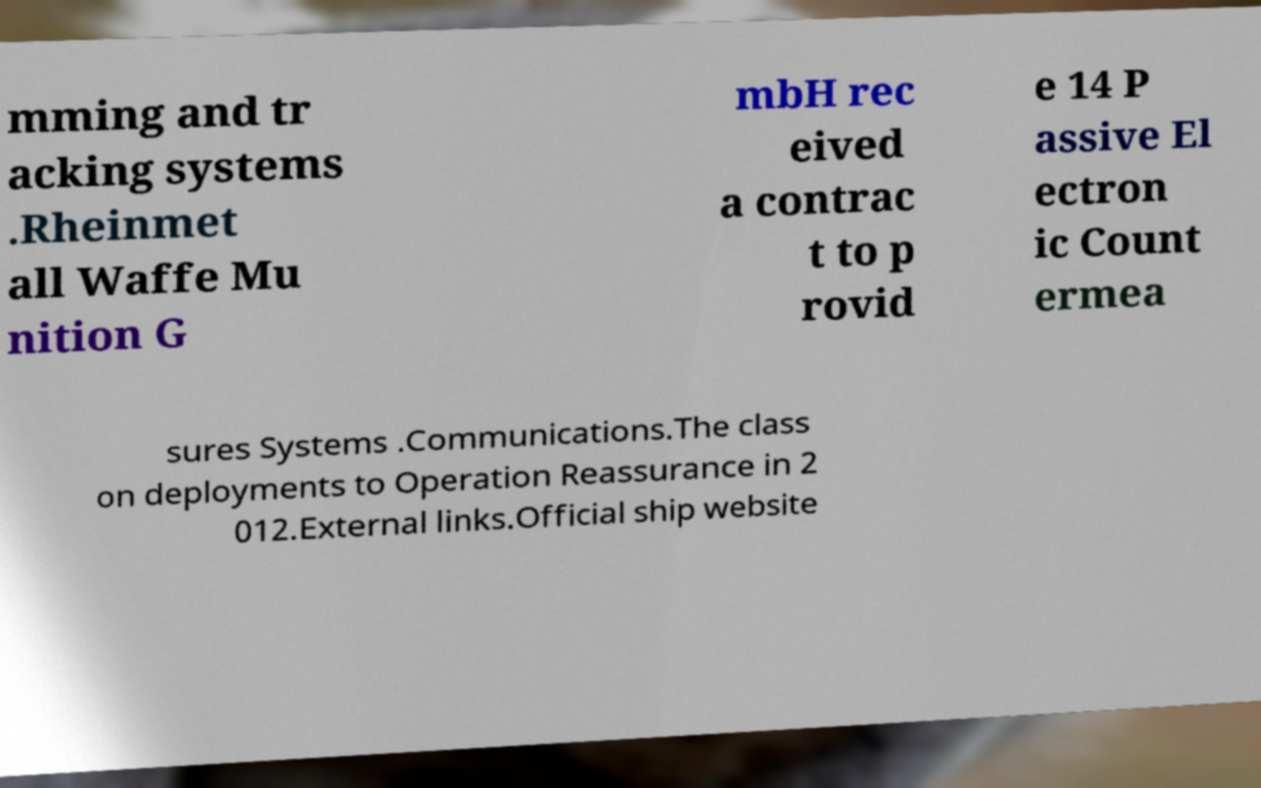What messages or text are displayed in this image? I need them in a readable, typed format. mming and tr acking systems .Rheinmet all Waffe Mu nition G mbH rec eived a contrac t to p rovid e 14 P assive El ectron ic Count ermea sures Systems .Communications.The class on deployments to Operation Reassurance in 2 012.External links.Official ship website 